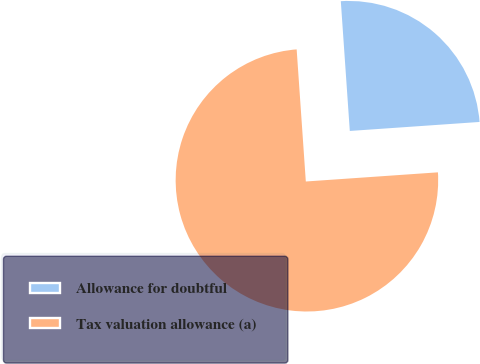Convert chart to OTSL. <chart><loc_0><loc_0><loc_500><loc_500><pie_chart><fcel>Allowance for doubtful<fcel>Tax valuation allowance (a)<nl><fcel>25.0%<fcel>75.0%<nl></chart> 